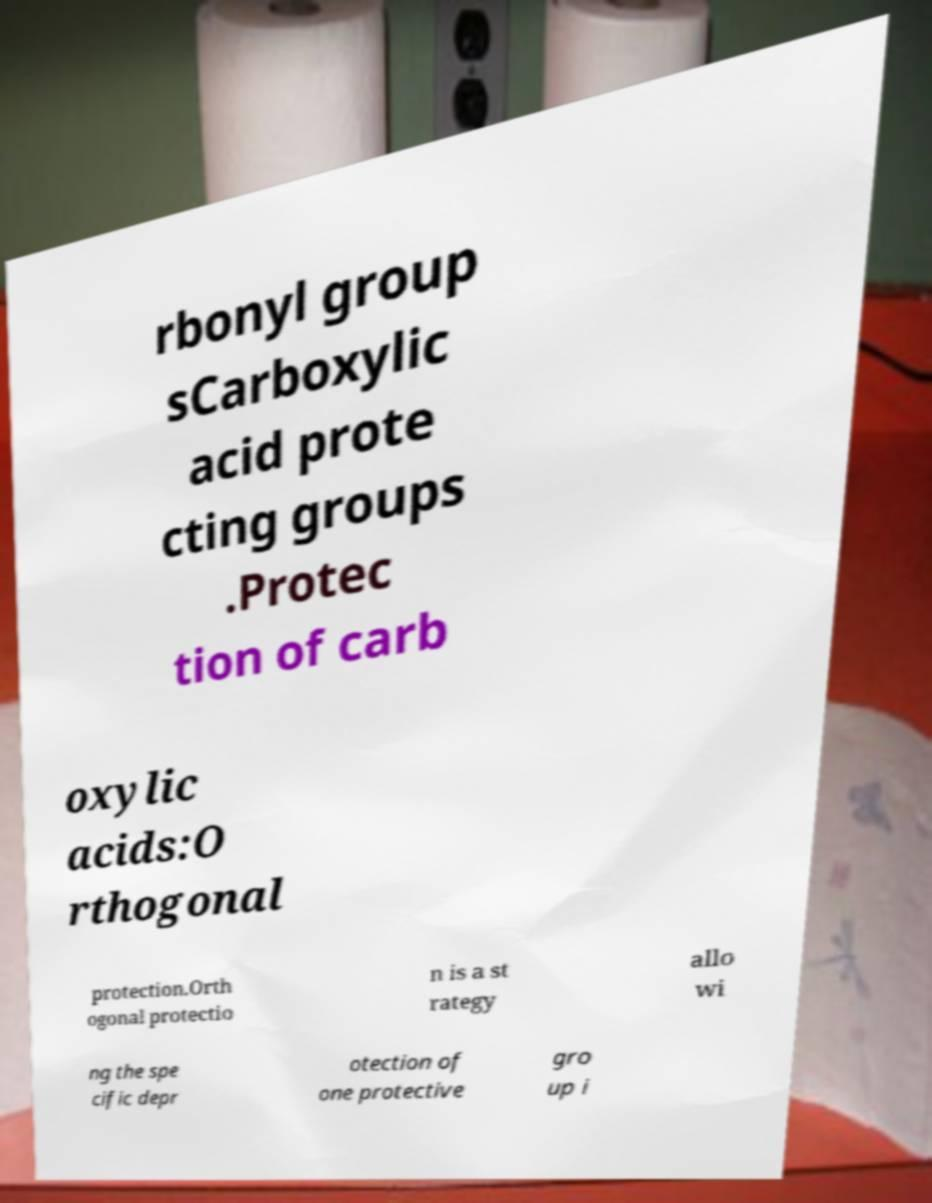There's text embedded in this image that I need extracted. Can you transcribe it verbatim? rbonyl group sCarboxylic acid prote cting groups .Protec tion of carb oxylic acids:O rthogonal protection.Orth ogonal protectio n is a st rategy allo wi ng the spe cific depr otection of one protective gro up i 